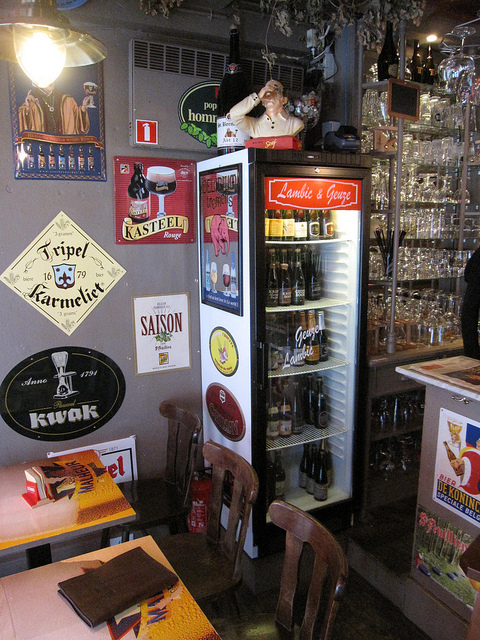How many chairs are there? There are three chairs in the image, each with a unique wooden design, situated around a small table, which together create a cozy seating area reminiscent of a traditional European café. 